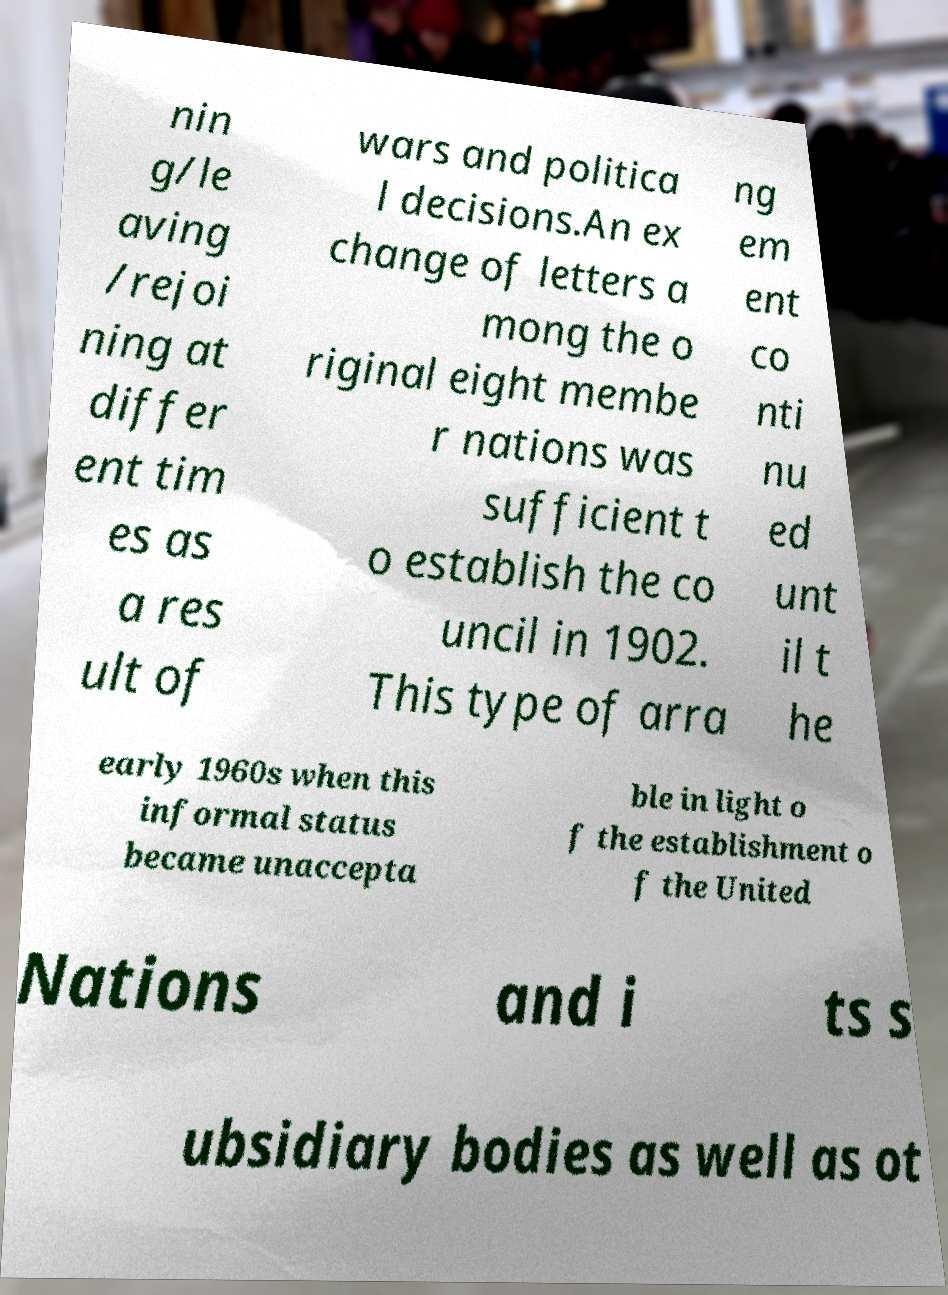Can you accurately transcribe the text from the provided image for me? nin g/le aving /rejoi ning at differ ent tim es as a res ult of wars and politica l decisions.An ex change of letters a mong the o riginal eight membe r nations was sufficient t o establish the co uncil in 1902. This type of arra ng em ent co nti nu ed unt il t he early 1960s when this informal status became unaccepta ble in light o f the establishment o f the United Nations and i ts s ubsidiary bodies as well as ot 